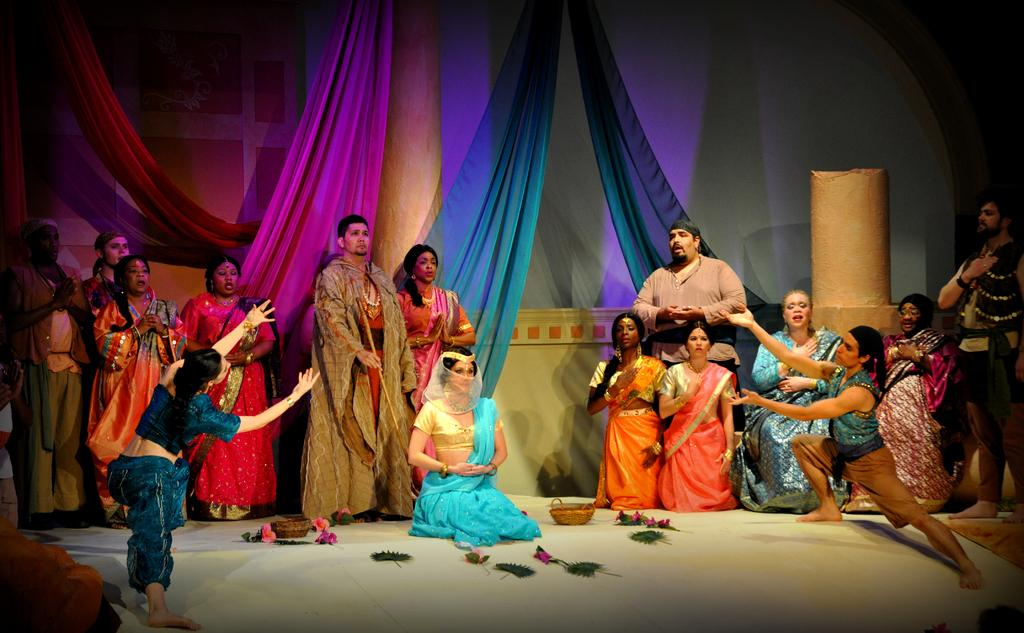Who is present in the image? There are people in the image. What are the people wearing? The people are wearing costumes. What can be seen in the background of the image? There are curtains in the background of the image. What objects are present in the image besides the people? There are baskets in the image. What type of hate is being expressed by the people in the image? There is no indication of hate or any negative emotion being expressed in the image; the people are wearing costumes and there is no context provided to suggest any negative feelings. 